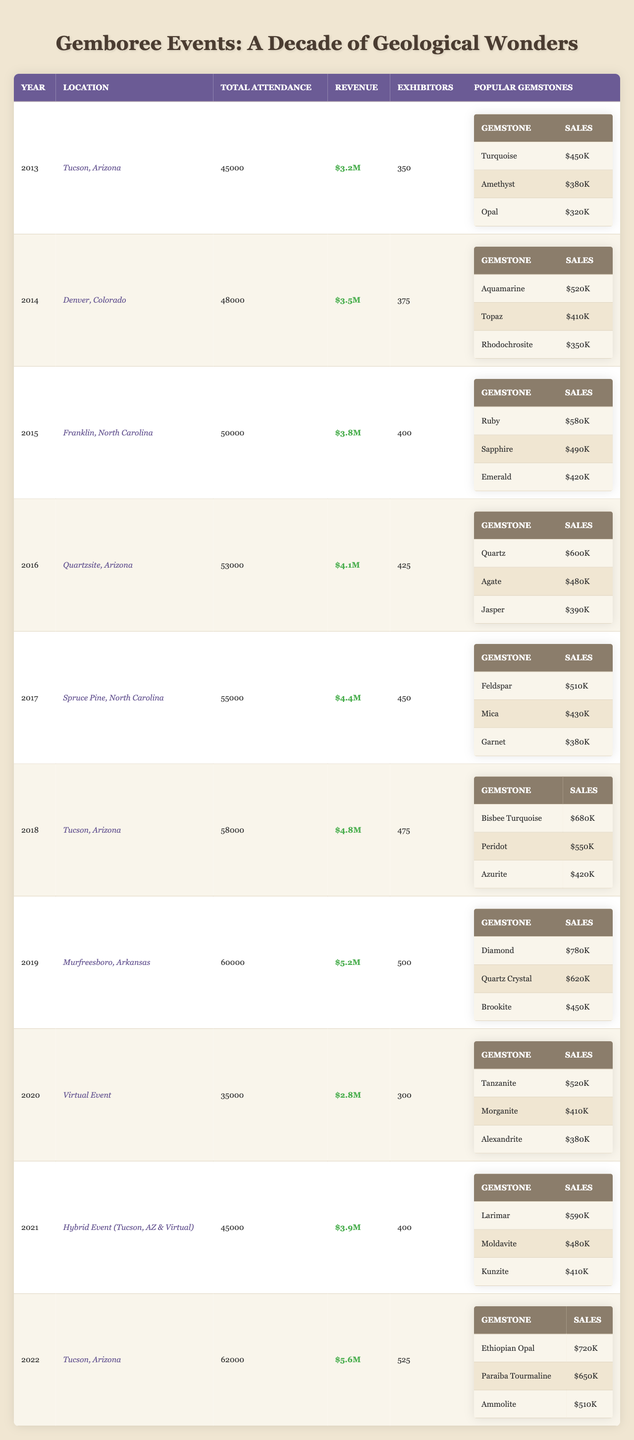What was the total attendance in 2016? Referring to the table under the Year 2016, the Total Attendance is stated as 53,000.
Answer: 53,000 Which event had the highest revenue? In the table, 2022 has the highest Revenue of $5.6M.
Answer: $5.6M How many exhibitors participated in the Gemboree event in 2015? Looking at the Year 2015 in the table, it shows that there were 400 Exhibitors.
Answer: 400 What is the average attendance from 2013 to 2022? The total attendance over the years is 45000 + 48000 + 50000 + 53000 + 55000 + 58000 + 60000 + 35000 + 45000 + 62000 = 4,080,000, and dividing that by the number of events (10) gives an average attendance of 408,000 / 10 = 40800.
Answer: 40800 Which gemstone had the highest sales in 2019? In the Gemboree event of 2019, Diamond had the highest sales of $780K according to the Popular Gemstones section.
Answer: $780K Did the total attendance increase every year from 2013 to 2022? Looking at the total attendance figures year by year, it increased from 45,000 in 2013 to 62,000 in 2022, except for 2020, which dropped to 35,000; thus the statement is false.
Answer: No How much more revenue was generated in 2022 compared to 2014? For 2022, the Revenue is $5.6M and for 2014, it is $3.5M. So, the difference in revenue is $5.6M - $3.5M = $2.1M.
Answer: $2.1M What was the total sales for Aquamarine and Topaz combined in 2014? From 2014’s Popular Gemstones data, Aquamarine had sales of $520K and Topaz had sales of $410K. Summing these gives $520K + $410K = $930K in total sales.
Answer: $930K Which year's event had the least total attendance? Reviewing the attendance numbers, 2020 had the least total attendance of 35,000, compared to other years listed.
Answer: 35,000 What percentage of total attendance in 2021 was represented by the attendance in 2020? The total attendance in 2021 was 45,000 and in 2020 was 35,000. The percentage is calculated as (35,000/45,000) * 100 = 77.78%.
Answer: 77.78% 